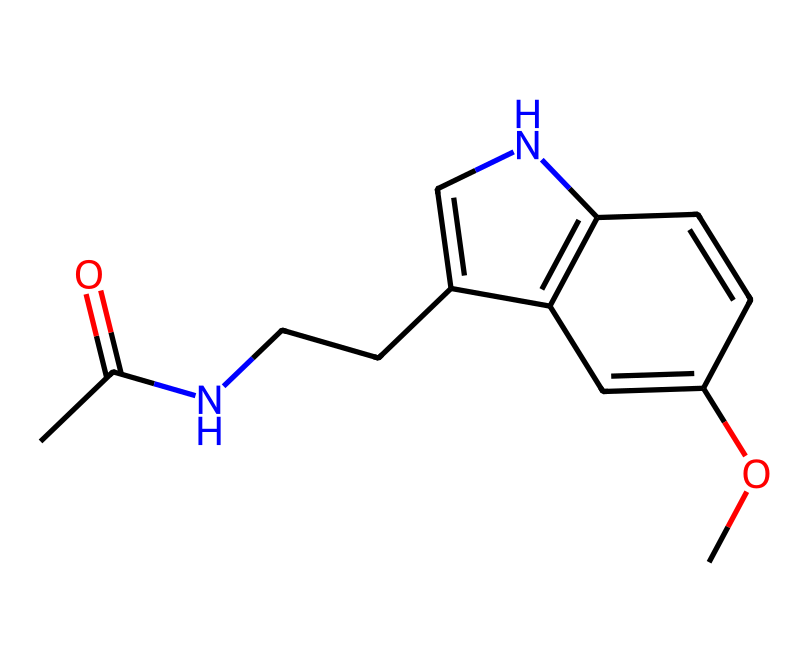What is the molecular formula of melatonin? To determine the molecular formula, we need to count the number of each type of atom in the SMILES representation. The SMILES indicates carbon (C), hydrogen (H), nitrogen (N), and oxygen (O) atoms. Counting these gives us C13H16N2O2.
Answer: C13H16N2O2 How many nitrogen atoms are present in melatonin? By examining the SMILES representation, we identify the 'N' symbols, which represent nitrogen atoms. There are two 'N' symbols in the structure.
Answer: 2 What type of hormone is melatonin classified as? Melatonin is classified as a hormone that is primarily involved in regulating sleep-wake cycles. Its structure indicates it is derived from tryptophan, which reinforces its classification as a hormone.
Answer: sleep hormone How does melatonin influence an athlete's sleep cycle? Melatonin influences the sleep cycle by signaling to the body that it is time to prepare for sleep, thus helping to regulate circadian rhythms, which is crucial for recovery and performance in athletes.
Answer: regulates circadian rhythms Which functional groups are present in melatonin? The SMILES shows an amide group (due to the CC(=O)N) and a methoxy group (–OCH3) in the structure. Identifying these groups helps understand its chemical behavior and interactions.
Answer: amide and methoxy groups What is the effect of melatonin on performance recovery for athletes? Melatonin can improve sleep quality, which enhances recovery processes such as muscle repair and mental fatigue in athletes, leading to better overall performance.
Answer: improves recovery processes 